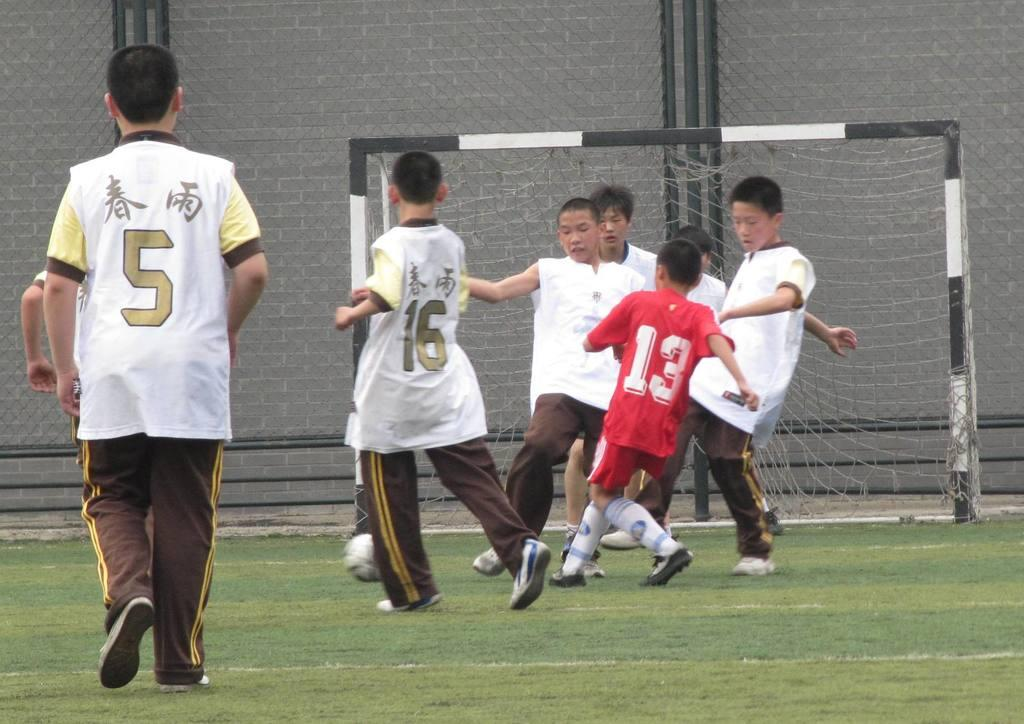<image>
Relay a brief, clear account of the picture shown. Player number 13 in a red jersey runs into a group of boys in white jerseys. 